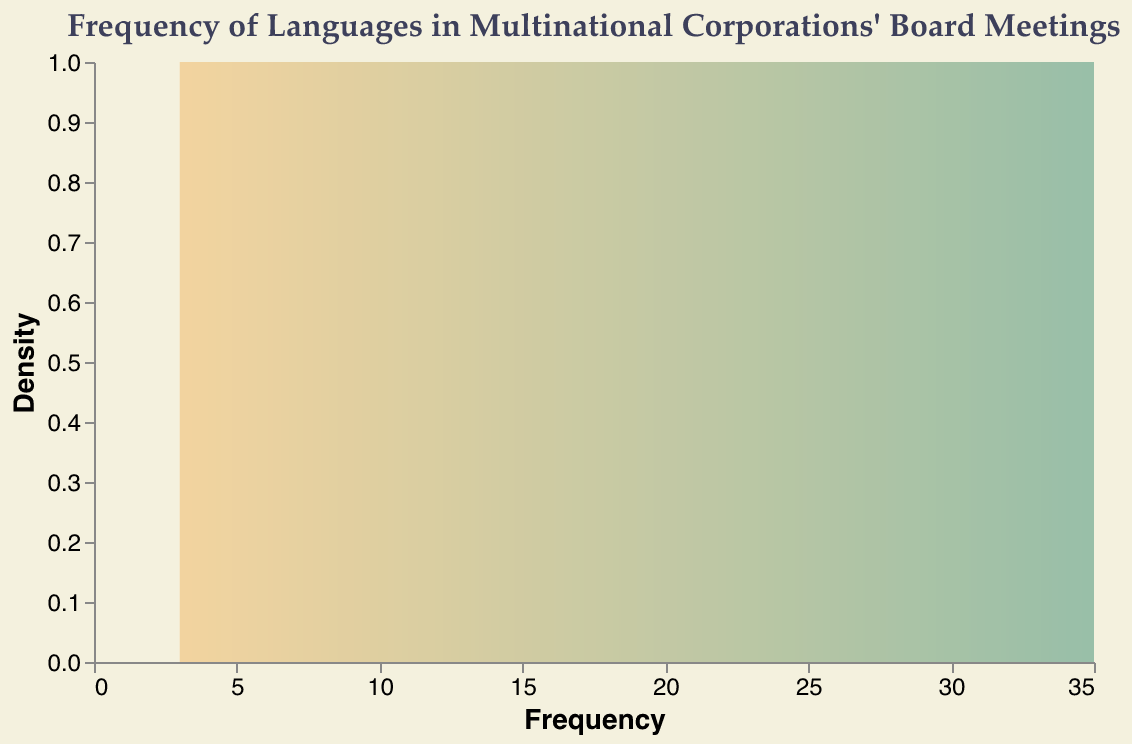What is the title of the plot? The title is prominently displayed at the top of the plot.
Answer: "Frequency of Languages in Multinational Corporations' Board Meetings" How many languages are represented in the density plot? We can count the number of unique data points corresponding to different languages on the x-axis.
Answer: 10 Which language has the highest frequency? The frequency values are displayed along the x-axis; the language with the highest value is the one with the highest bar.
Answer: English What is the density value with the highest frequency value? The x-axis represents frequency, and the y-axis represents density. Identifying the bar with the highest x-value and referencing its y-value will give us the answer.
Answer: 1 What is the sum of the frequencies of Mandarin and French? Mandarin has a frequency of 20 and French has a frequency of 12. Summing these values gives 20 + 12.
Answer: 32 Which two languages have the closest frequencies? Observing the frequency axis and values, we identify the frequencies that are nearest to each other.
Answer: Arabic and Japanese What is the average frequency of the top three most frequently spoken languages? The top three languages by frequency are English (35), Mandarin (20), and French (12). Their average frequency is calculated as (35 + 20 + 12) / 3.
Answer: 22.33 What is the difference in frequency between the most frequently spoken language and the least frequently spoken language? Subtract the lowest frequency value (Hindi's 3) from the highest frequency value (English's 35).
Answer: 32 Are there more languages with a frequency greater than 10 or less than 10? Count the languages with frequencies greater than 10 and compare with those less than 10. Languages greater than 10: English, Mandarin, French. Languages less than 10: Spanish, German, Japanese, Portuguese, Russian, Hindi, Arabic.
Answer: Less than 10 How is the color gradient applied in the density plot? Observing the plot, the color gradient goes from a lighter color at low frequencies to a darker color at higher frequencies.
Answer: From #F2CC8F to #81B29A 